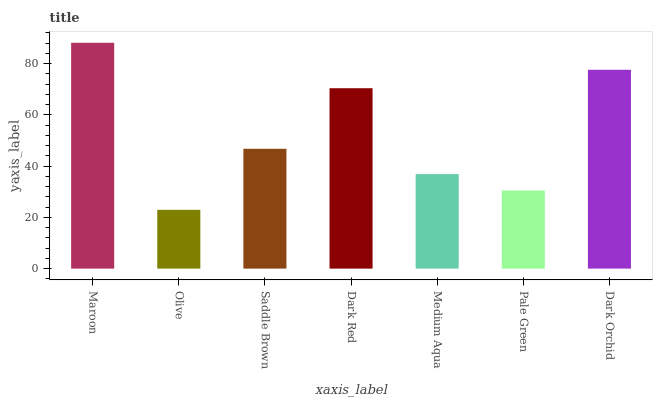Is Olive the minimum?
Answer yes or no. Yes. Is Maroon the maximum?
Answer yes or no. Yes. Is Saddle Brown the minimum?
Answer yes or no. No. Is Saddle Brown the maximum?
Answer yes or no. No. Is Saddle Brown greater than Olive?
Answer yes or no. Yes. Is Olive less than Saddle Brown?
Answer yes or no. Yes. Is Olive greater than Saddle Brown?
Answer yes or no. No. Is Saddle Brown less than Olive?
Answer yes or no. No. Is Saddle Brown the high median?
Answer yes or no. Yes. Is Saddle Brown the low median?
Answer yes or no. Yes. Is Pale Green the high median?
Answer yes or no. No. Is Pale Green the low median?
Answer yes or no. No. 